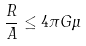Convert formula to latex. <formula><loc_0><loc_0><loc_500><loc_500>\frac { R } { A } \leq 4 \pi G \mu</formula> 